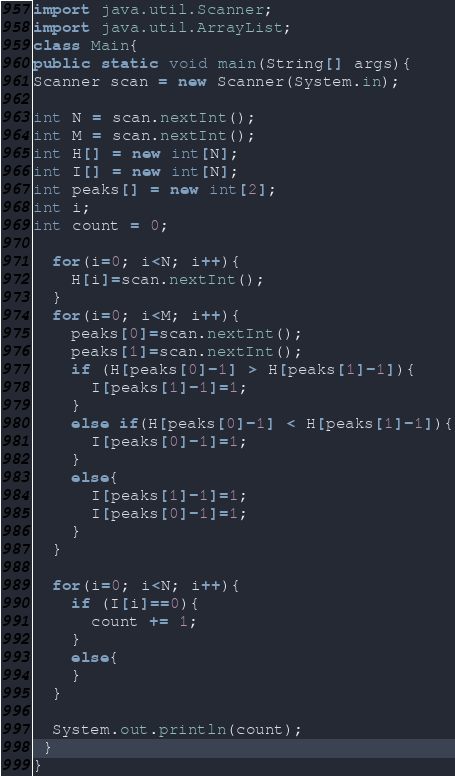<code> <loc_0><loc_0><loc_500><loc_500><_Java_>import java.util.Scanner;
import java.util.ArrayList;
class Main{
public static void main(String[] args){
Scanner scan = new Scanner(System.in);
 
int N = scan.nextInt();
int M = scan.nextInt();
int H[] = new int[N];
int I[] = new int[N];
int peaks[] = new int[2];
int i;
int count = 0;

  for(i=0; i<N; i++){
    H[i]=scan.nextInt();
  }
  for(i=0; i<M; i++){
    peaks[0]=scan.nextInt();
    peaks[1]=scan.nextInt();
    if (H[peaks[0]-1] > H[peaks[1]-1]){
      I[peaks[1]-1]=1;
    }
    else if(H[peaks[0]-1] < H[peaks[1]-1]){
      I[peaks[0]-1]=1;
    }
    else{
      I[peaks[1]-1]=1;
      I[peaks[0]-1]=1;
    }
  }
  
  for(i=0; i<N; i++){
    if (I[i]==0){
      count += 1;
    }
    else{
    }
  }
  
  System.out.println(count);
 }
}</code> 